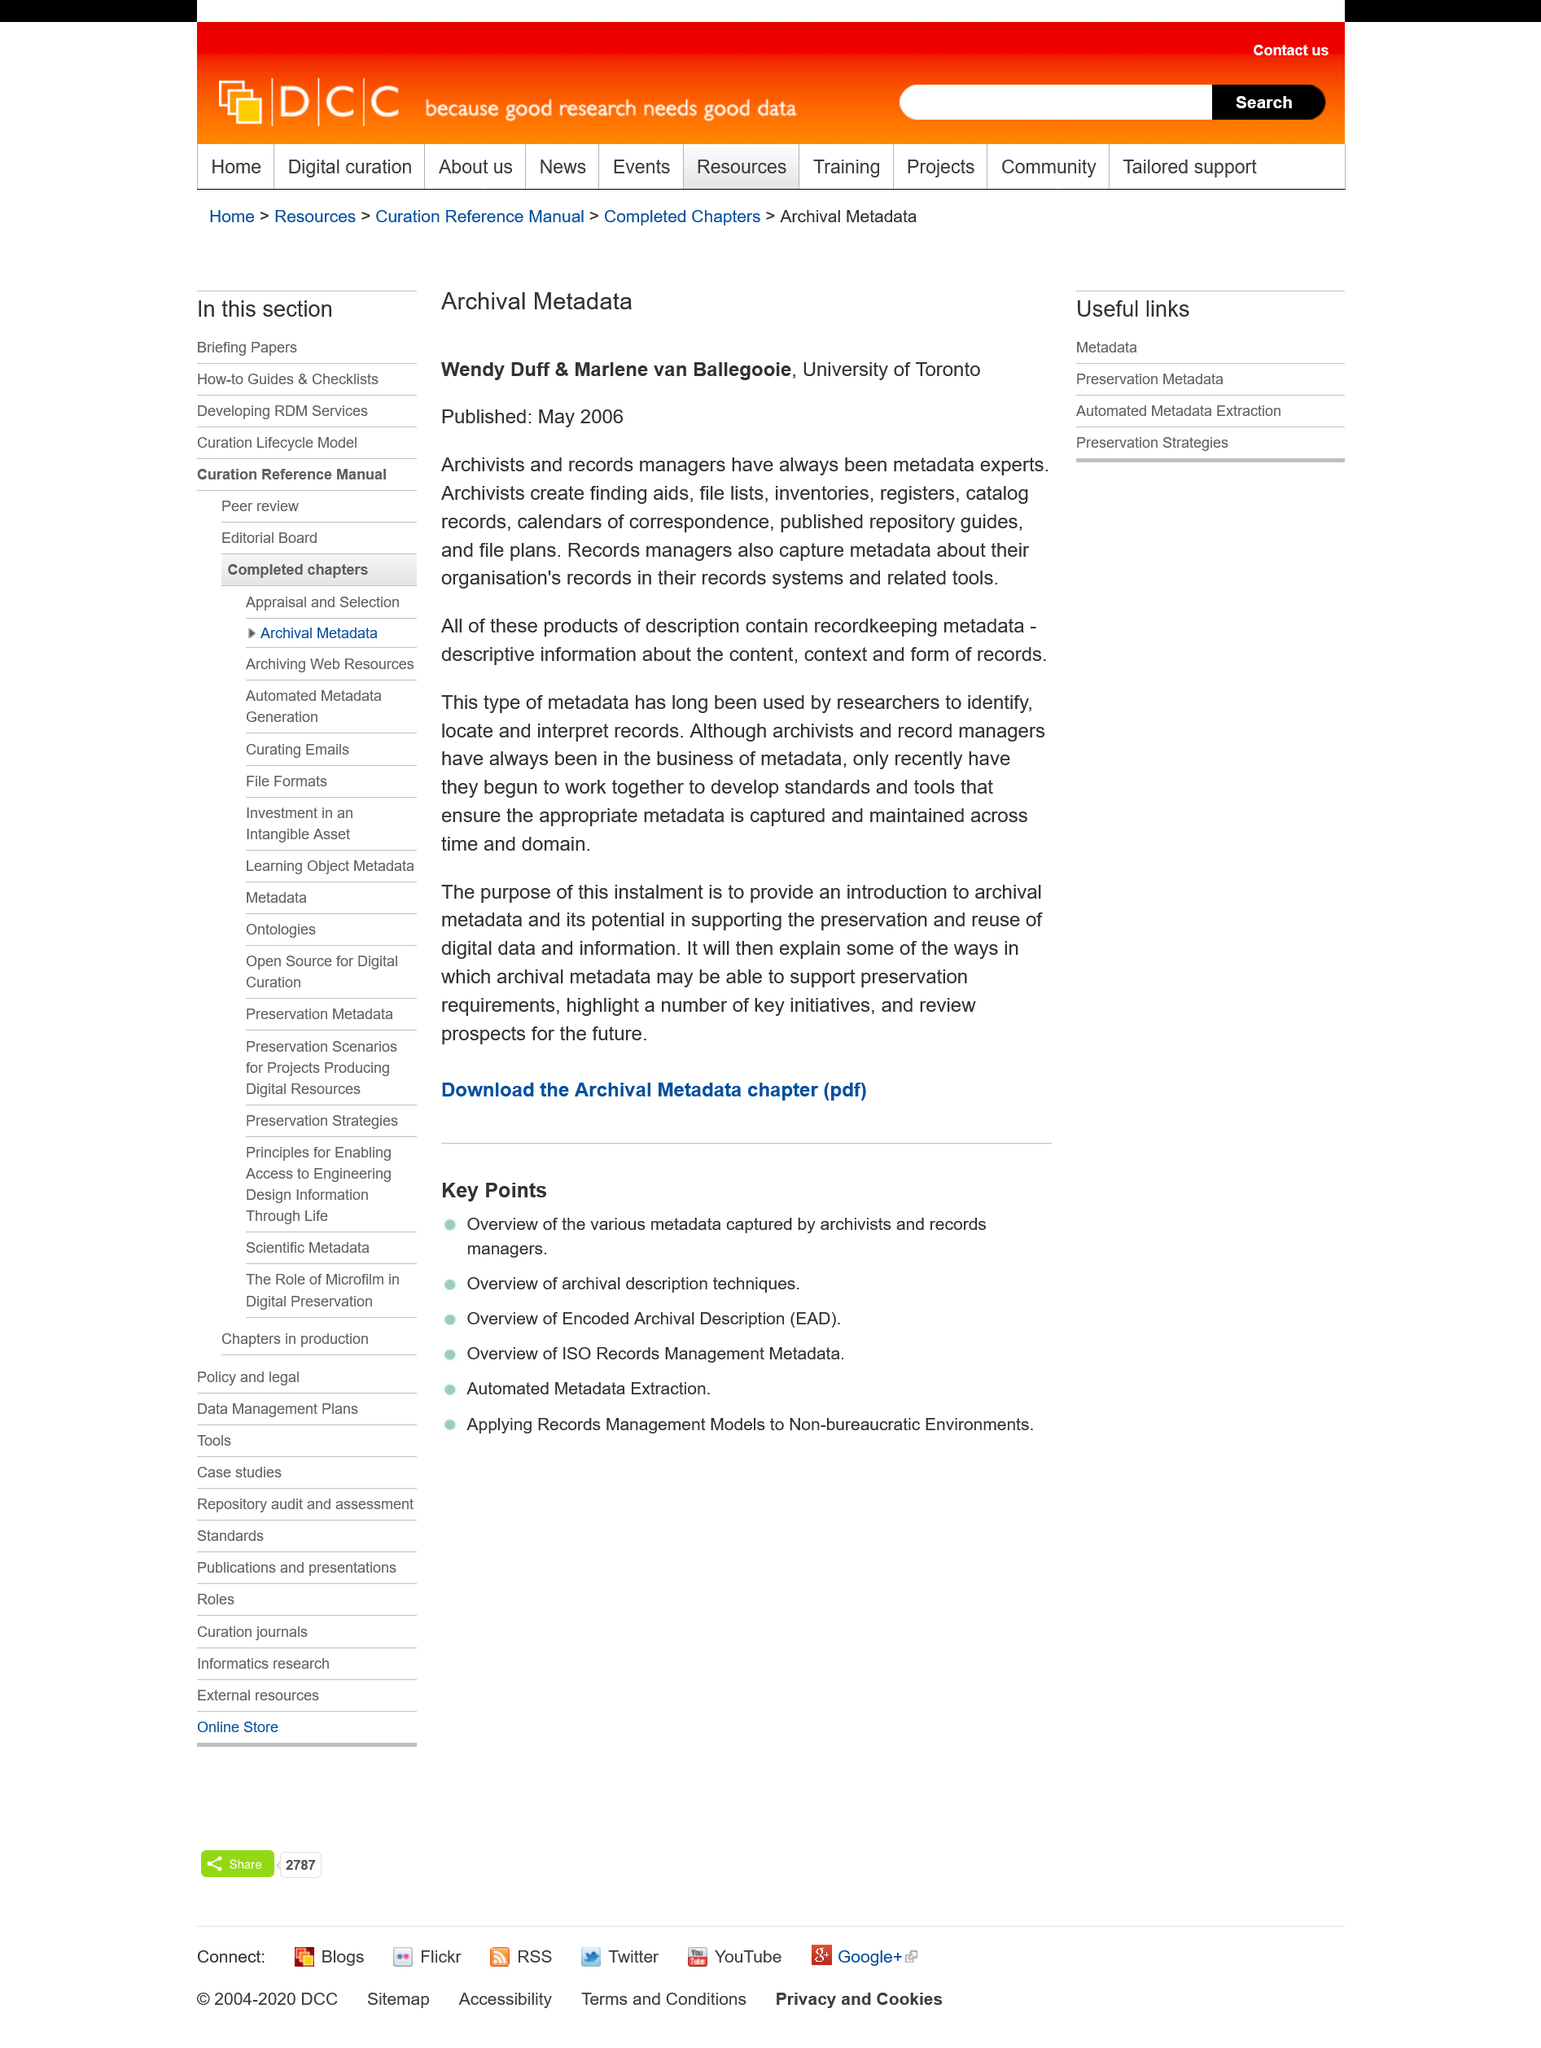List a handful of essential elements in this visual. The article titled "Archival Metadata" by Wendy Duff and Marlene van Ballegoole was published in May 2006. Recordkeeping metadata includes descriptive information about the content, context, and form of records, which are the characteristic parts of recordkeeping. Wendy Duff and Marlene van Ballegoole are currently employed at the University of Toronto. 